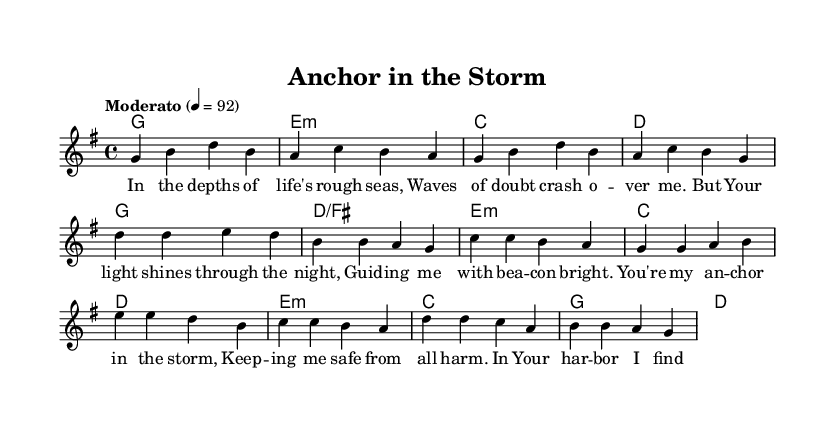What is the key signature of this music? The key signature is G major, which has one sharp (F#). This is indicated at the beginning of the staff where the key signature is placed.
Answer: G major What is the time signature of this piece? The time signature is 4/4, which means there are four beats in each measure and a quarter note receives one beat. This is specified at the beginning of the score next to the key signature.
Answer: 4/4 What is the tempo marking for this piece? The tempo marking is "Moderato" with a metronome marking of 92, indicating a moderate speed. This can be found near the beginning of the sheet music.
Answer: Moderato How many bars are there in the verse? There are eight bars in the verse, which can be counted by observing the measures in the melody section of the score.
Answer: Eight What phrase describes the theme of the lyrics? The theme revolves around faith and guidance through life's challenges, highlighted by nautical metaphors such as "anchor" and "harbor." This theme is captured in the wording of the lyrics for both the verse and the chorus.
Answer: Faith and guidance What is the structure of the song? The structure consists of a verse followed by a chorus, and then a bridge. Each section can be identified by its respective lyrics written in the score.
Answer: Verse, Chorus, Bridge 